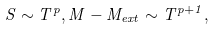<formula> <loc_0><loc_0><loc_500><loc_500>S \sim T ^ { p } , M - M _ { e x t } \sim T ^ { p + 1 } ,</formula> 